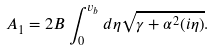Convert formula to latex. <formula><loc_0><loc_0><loc_500><loc_500>A _ { 1 } = 2 B \int ^ { v _ { b } } _ { 0 } d \eta \sqrt { \gamma + \alpha ^ { 2 } ( i \eta ) } .</formula> 